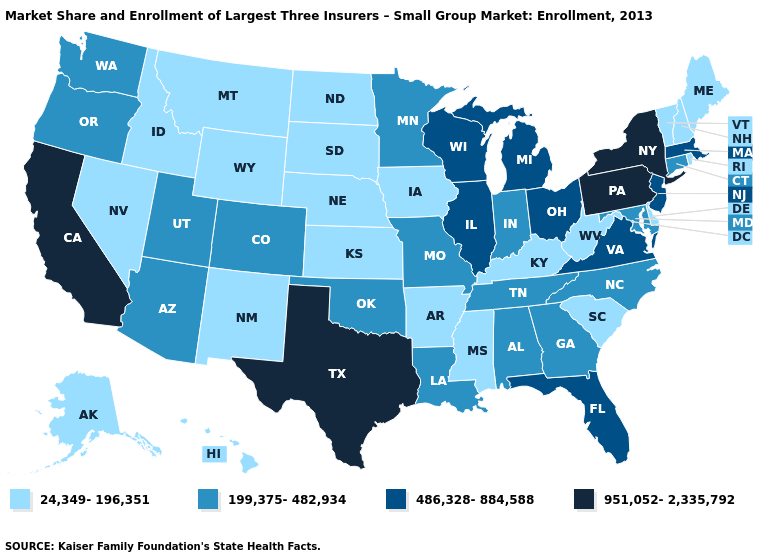What is the lowest value in states that border West Virginia?
Write a very short answer. 24,349-196,351. Which states have the lowest value in the Northeast?
Concise answer only. Maine, New Hampshire, Rhode Island, Vermont. Name the states that have a value in the range 24,349-196,351?
Answer briefly. Alaska, Arkansas, Delaware, Hawaii, Idaho, Iowa, Kansas, Kentucky, Maine, Mississippi, Montana, Nebraska, Nevada, New Hampshire, New Mexico, North Dakota, Rhode Island, South Carolina, South Dakota, Vermont, West Virginia, Wyoming. Among the states that border Virginia , does West Virginia have the lowest value?
Answer briefly. Yes. Does Florida have the lowest value in the South?
Write a very short answer. No. What is the highest value in the USA?
Keep it brief. 951,052-2,335,792. Does the first symbol in the legend represent the smallest category?
Be succinct. Yes. Name the states that have a value in the range 199,375-482,934?
Give a very brief answer. Alabama, Arizona, Colorado, Connecticut, Georgia, Indiana, Louisiana, Maryland, Minnesota, Missouri, North Carolina, Oklahoma, Oregon, Tennessee, Utah, Washington. Is the legend a continuous bar?
Keep it brief. No. Does Illinois have the same value as Vermont?
Short answer required. No. Which states have the highest value in the USA?
Answer briefly. California, New York, Pennsylvania, Texas. Does Nebraska have the same value as Pennsylvania?
Short answer required. No. Name the states that have a value in the range 199,375-482,934?
Answer briefly. Alabama, Arizona, Colorado, Connecticut, Georgia, Indiana, Louisiana, Maryland, Minnesota, Missouri, North Carolina, Oklahoma, Oregon, Tennessee, Utah, Washington. What is the value of Ohio?
Write a very short answer. 486,328-884,588. Does Hawaii have the highest value in the West?
Quick response, please. No. 